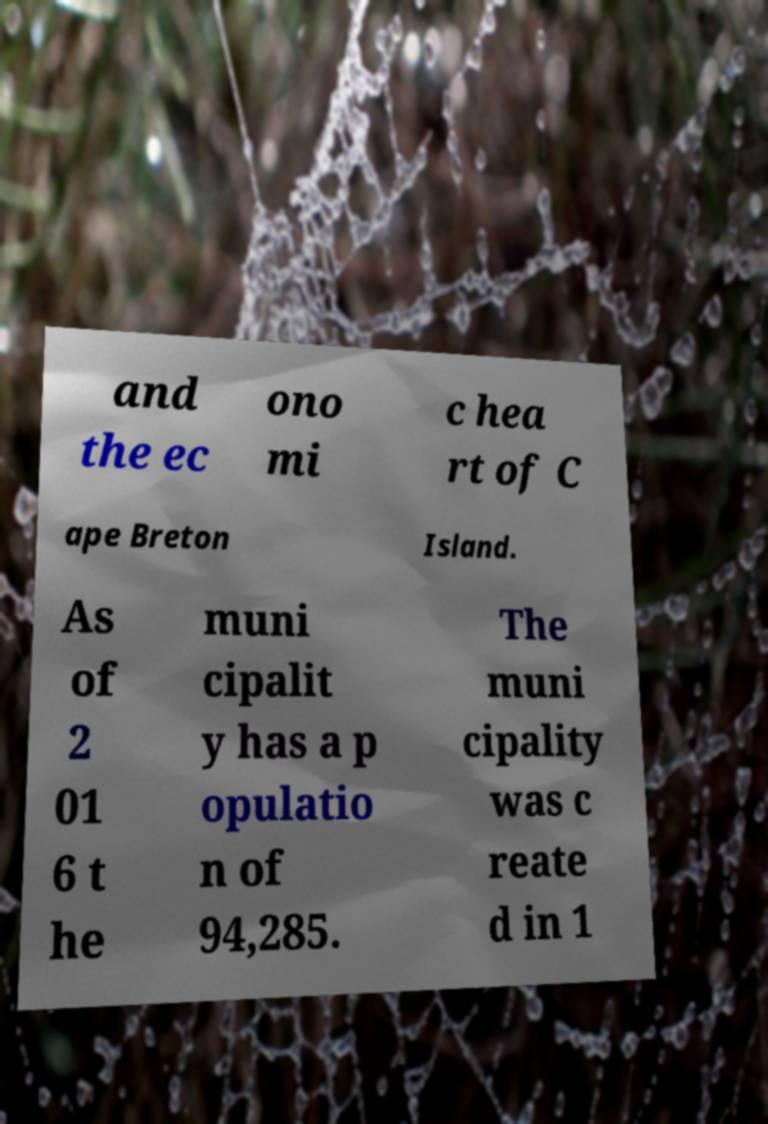Could you extract and type out the text from this image? and the ec ono mi c hea rt of C ape Breton Island. As of 2 01 6 t he muni cipalit y has a p opulatio n of 94,285. The muni cipality was c reate d in 1 